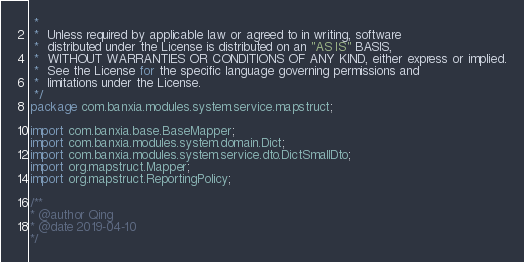<code> <loc_0><loc_0><loc_500><loc_500><_Java_> *
 *  Unless required by applicable law or agreed to in writing, software
 *  distributed under the License is distributed on an "AS IS" BASIS,
 *  WITHOUT WARRANTIES OR CONDITIONS OF ANY KIND, either express or implied.
 *  See the License for the specific language governing permissions and
 *  limitations under the License.
 */
package com.banxia.modules.system.service.mapstruct;

import com.banxia.base.BaseMapper;
import com.banxia.modules.system.domain.Dict;
import com.banxia.modules.system.service.dto.DictSmallDto;
import org.mapstruct.Mapper;
import org.mapstruct.ReportingPolicy;

/**
* @author Qing
* @date 2019-04-10
*/</code> 